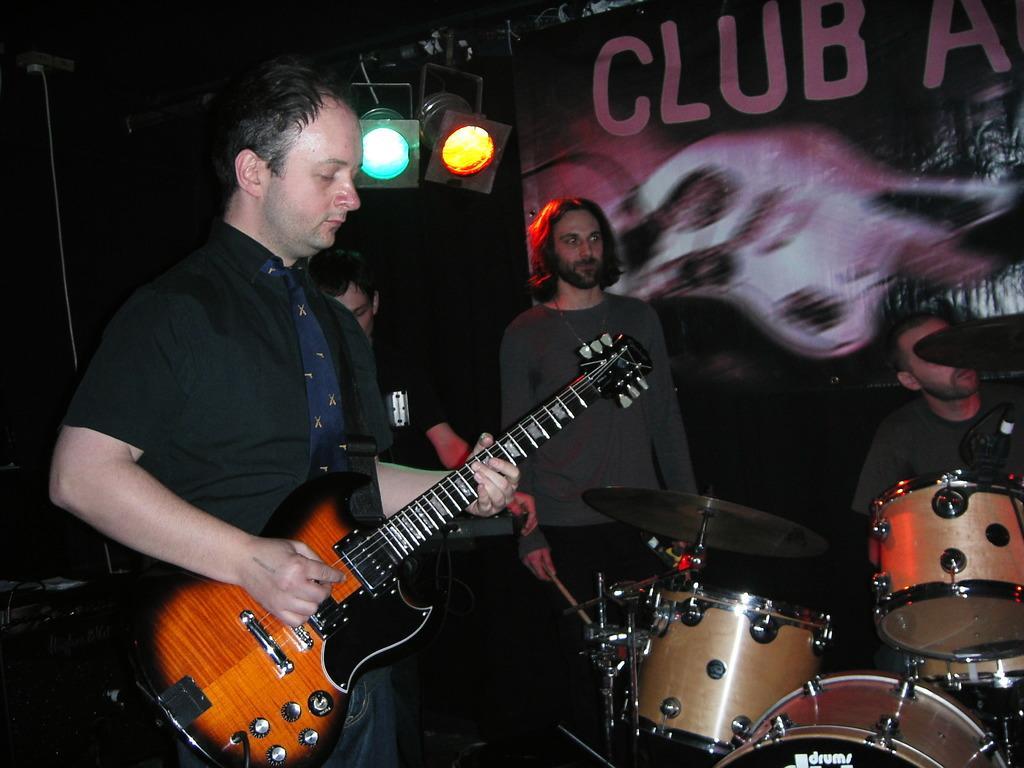Describe this image in one or two sentences. in this image there could be 4 persons and one person is playing the guitar and the two persons they are playing the drums and one person he is playing the keyboard and the background is very dark and behind the persons the two light are there. 